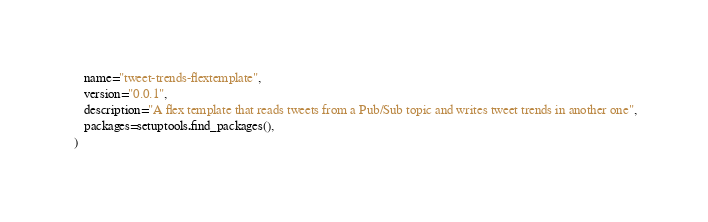<code> <loc_0><loc_0><loc_500><loc_500><_Python_>    name="tweet-trends-flextemplate",
    version="0.0.1",
    description="A flex template that reads tweets from a Pub/Sub topic and writes tweet trends in another one",
    packages=setuptools.find_packages(),
 )
</code> 